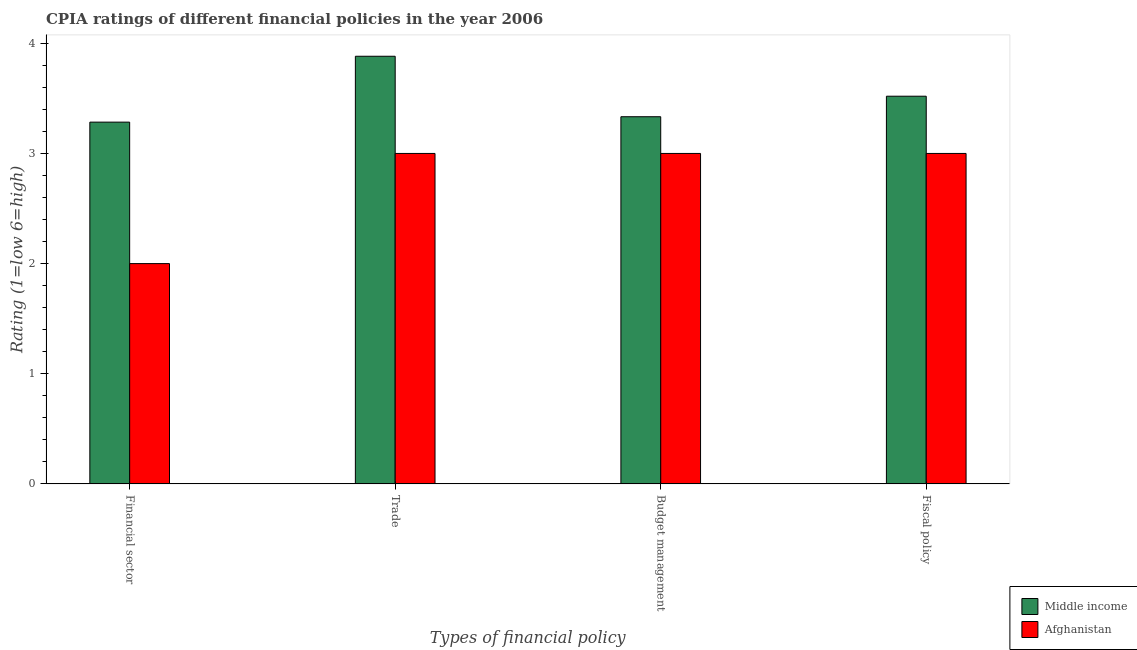How many different coloured bars are there?
Offer a very short reply. 2. How many groups of bars are there?
Your response must be concise. 4. What is the label of the 4th group of bars from the left?
Your answer should be very brief. Fiscal policy. What is the cpia rating of financial sector in Afghanistan?
Offer a terse response. 2. Across all countries, what is the maximum cpia rating of budget management?
Make the answer very short. 3.33. In which country was the cpia rating of trade maximum?
Your response must be concise. Middle income. In which country was the cpia rating of budget management minimum?
Make the answer very short. Afghanistan. What is the total cpia rating of budget management in the graph?
Provide a succinct answer. 6.33. What is the difference between the cpia rating of budget management in Afghanistan and that in Middle income?
Offer a very short reply. -0.33. What is the difference between the cpia rating of trade in Middle income and the cpia rating of budget management in Afghanistan?
Offer a very short reply. 0.88. What is the average cpia rating of financial sector per country?
Make the answer very short. 2.64. In how many countries, is the cpia rating of fiscal policy greater than 1.8 ?
Give a very brief answer. 2. What is the ratio of the cpia rating of budget management in Afghanistan to that in Middle income?
Your answer should be very brief. 0.9. Is the cpia rating of trade in Middle income less than that in Afghanistan?
Keep it short and to the point. No. Is the difference between the cpia rating of financial sector in Middle income and Afghanistan greater than the difference between the cpia rating of trade in Middle income and Afghanistan?
Keep it short and to the point. Yes. What is the difference between the highest and the second highest cpia rating of fiscal policy?
Keep it short and to the point. 0.52. What is the difference between the highest and the lowest cpia rating of trade?
Provide a short and direct response. 0.88. In how many countries, is the cpia rating of budget management greater than the average cpia rating of budget management taken over all countries?
Make the answer very short. 1. Is the sum of the cpia rating of fiscal policy in Afghanistan and Middle income greater than the maximum cpia rating of budget management across all countries?
Your answer should be compact. Yes. Is it the case that in every country, the sum of the cpia rating of trade and cpia rating of fiscal policy is greater than the sum of cpia rating of financial sector and cpia rating of budget management?
Ensure brevity in your answer.  No. What does the 2nd bar from the left in Fiscal policy represents?
Your answer should be very brief. Afghanistan. What does the 1st bar from the right in Fiscal policy represents?
Provide a succinct answer. Afghanistan. How many countries are there in the graph?
Keep it short and to the point. 2. What is the difference between two consecutive major ticks on the Y-axis?
Your response must be concise. 1. Does the graph contain any zero values?
Provide a short and direct response. No. What is the title of the graph?
Your response must be concise. CPIA ratings of different financial policies in the year 2006. Does "Somalia" appear as one of the legend labels in the graph?
Your answer should be compact. No. What is the label or title of the X-axis?
Provide a succinct answer. Types of financial policy. What is the label or title of the Y-axis?
Provide a short and direct response. Rating (1=low 6=high). What is the Rating (1=low 6=high) of Middle income in Financial sector?
Offer a terse response. 3.28. What is the Rating (1=low 6=high) in Middle income in Trade?
Give a very brief answer. 3.88. What is the Rating (1=low 6=high) in Middle income in Budget management?
Keep it short and to the point. 3.33. What is the Rating (1=low 6=high) of Afghanistan in Budget management?
Provide a short and direct response. 3. What is the Rating (1=low 6=high) of Middle income in Fiscal policy?
Provide a succinct answer. 3.52. Across all Types of financial policy, what is the maximum Rating (1=low 6=high) in Middle income?
Your answer should be compact. 3.88. Across all Types of financial policy, what is the maximum Rating (1=low 6=high) of Afghanistan?
Your answer should be very brief. 3. Across all Types of financial policy, what is the minimum Rating (1=low 6=high) of Middle income?
Provide a short and direct response. 3.28. Across all Types of financial policy, what is the minimum Rating (1=low 6=high) in Afghanistan?
Offer a very short reply. 2. What is the total Rating (1=low 6=high) of Middle income in the graph?
Your answer should be compact. 14.02. What is the total Rating (1=low 6=high) in Afghanistan in the graph?
Your answer should be very brief. 11. What is the difference between the Rating (1=low 6=high) in Middle income in Financial sector and that in Trade?
Give a very brief answer. -0.6. What is the difference between the Rating (1=low 6=high) in Middle income in Financial sector and that in Budget management?
Make the answer very short. -0.05. What is the difference between the Rating (1=low 6=high) in Afghanistan in Financial sector and that in Budget management?
Offer a very short reply. -1. What is the difference between the Rating (1=low 6=high) in Middle income in Financial sector and that in Fiscal policy?
Your answer should be compact. -0.24. What is the difference between the Rating (1=low 6=high) of Middle income in Trade and that in Budget management?
Your answer should be compact. 0.55. What is the difference between the Rating (1=low 6=high) in Afghanistan in Trade and that in Budget management?
Your response must be concise. 0. What is the difference between the Rating (1=low 6=high) of Middle income in Trade and that in Fiscal policy?
Offer a very short reply. 0.36. What is the difference between the Rating (1=low 6=high) of Middle income in Budget management and that in Fiscal policy?
Your response must be concise. -0.19. What is the difference between the Rating (1=low 6=high) in Afghanistan in Budget management and that in Fiscal policy?
Your answer should be very brief. 0. What is the difference between the Rating (1=low 6=high) of Middle income in Financial sector and the Rating (1=low 6=high) of Afghanistan in Trade?
Give a very brief answer. 0.28. What is the difference between the Rating (1=low 6=high) of Middle income in Financial sector and the Rating (1=low 6=high) of Afghanistan in Budget management?
Your answer should be compact. 0.28. What is the difference between the Rating (1=low 6=high) of Middle income in Financial sector and the Rating (1=low 6=high) of Afghanistan in Fiscal policy?
Give a very brief answer. 0.28. What is the difference between the Rating (1=low 6=high) of Middle income in Trade and the Rating (1=low 6=high) of Afghanistan in Budget management?
Ensure brevity in your answer.  0.88. What is the difference between the Rating (1=low 6=high) of Middle income in Trade and the Rating (1=low 6=high) of Afghanistan in Fiscal policy?
Provide a succinct answer. 0.88. What is the difference between the Rating (1=low 6=high) in Middle income in Budget management and the Rating (1=low 6=high) in Afghanistan in Fiscal policy?
Give a very brief answer. 0.33. What is the average Rating (1=low 6=high) in Middle income per Types of financial policy?
Your answer should be very brief. 3.5. What is the average Rating (1=low 6=high) of Afghanistan per Types of financial policy?
Your response must be concise. 2.75. What is the difference between the Rating (1=low 6=high) of Middle income and Rating (1=low 6=high) of Afghanistan in Financial sector?
Provide a short and direct response. 1.28. What is the difference between the Rating (1=low 6=high) of Middle income and Rating (1=low 6=high) of Afghanistan in Trade?
Give a very brief answer. 0.88. What is the difference between the Rating (1=low 6=high) in Middle income and Rating (1=low 6=high) in Afghanistan in Fiscal policy?
Provide a succinct answer. 0.52. What is the ratio of the Rating (1=low 6=high) in Middle income in Financial sector to that in Trade?
Keep it short and to the point. 0.85. What is the ratio of the Rating (1=low 6=high) of Afghanistan in Financial sector to that in Trade?
Your response must be concise. 0.67. What is the ratio of the Rating (1=low 6=high) in Afghanistan in Financial sector to that in Budget management?
Your response must be concise. 0.67. What is the ratio of the Rating (1=low 6=high) in Middle income in Financial sector to that in Fiscal policy?
Provide a short and direct response. 0.93. What is the ratio of the Rating (1=low 6=high) of Afghanistan in Financial sector to that in Fiscal policy?
Provide a succinct answer. 0.67. What is the ratio of the Rating (1=low 6=high) of Middle income in Trade to that in Budget management?
Keep it short and to the point. 1.16. What is the ratio of the Rating (1=low 6=high) of Afghanistan in Trade to that in Budget management?
Ensure brevity in your answer.  1. What is the ratio of the Rating (1=low 6=high) in Middle income in Trade to that in Fiscal policy?
Your response must be concise. 1.1. What is the ratio of the Rating (1=low 6=high) of Afghanistan in Trade to that in Fiscal policy?
Your answer should be compact. 1. What is the ratio of the Rating (1=low 6=high) of Middle income in Budget management to that in Fiscal policy?
Offer a very short reply. 0.95. What is the ratio of the Rating (1=low 6=high) in Afghanistan in Budget management to that in Fiscal policy?
Ensure brevity in your answer.  1. What is the difference between the highest and the second highest Rating (1=low 6=high) of Middle income?
Keep it short and to the point. 0.36. What is the difference between the highest and the lowest Rating (1=low 6=high) in Middle income?
Provide a short and direct response. 0.6. What is the difference between the highest and the lowest Rating (1=low 6=high) in Afghanistan?
Your response must be concise. 1. 